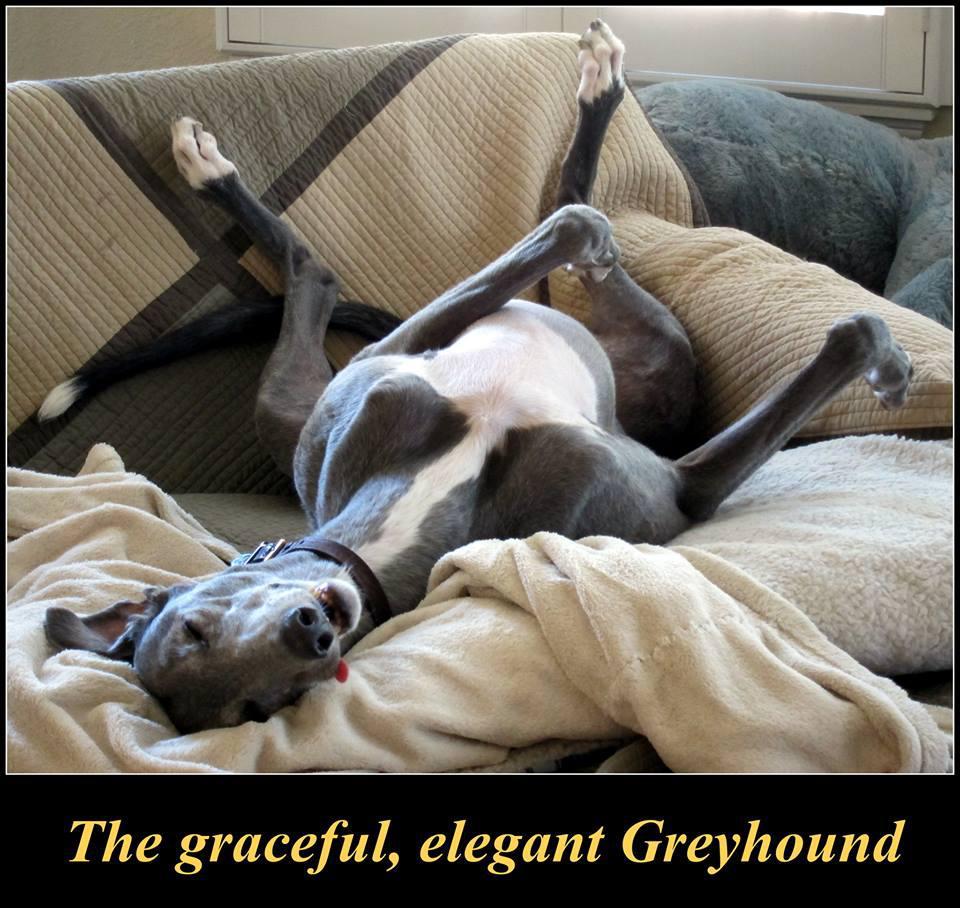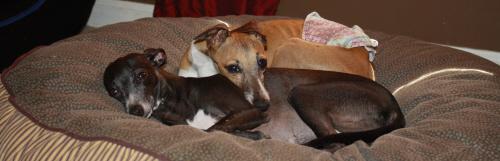The first image is the image on the left, the second image is the image on the right. Evaluate the accuracy of this statement regarding the images: "At least one of the images includes a dog interacting with an ice cream cone.". Is it true? Answer yes or no. No. The first image is the image on the left, the second image is the image on the right. Assess this claim about the two images: "There is two dogs in the right image.". Correct or not? Answer yes or no. Yes. 